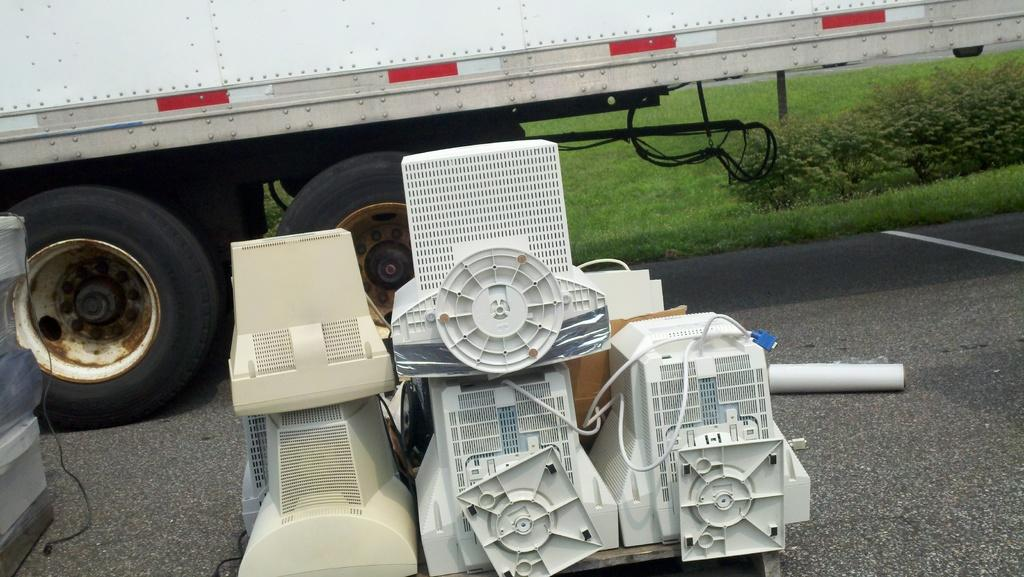What can be seen on the road surface in the image? There are machines on the road surface in the image. What part of a vehicle is visible in the image? There is a part of a truck with two wheels visible in the image. What type of surface is beside the truck in the image? There is a grass surface beside the truck in the image. What type of copper material is used to construct the machines in the image? There is no mention of copper material in the image, and the machines' construction materials are not specified. How does the fuel system work for the truck in the image? The image does not provide information about the truck's fuel system, so it cannot be determined from the image. 